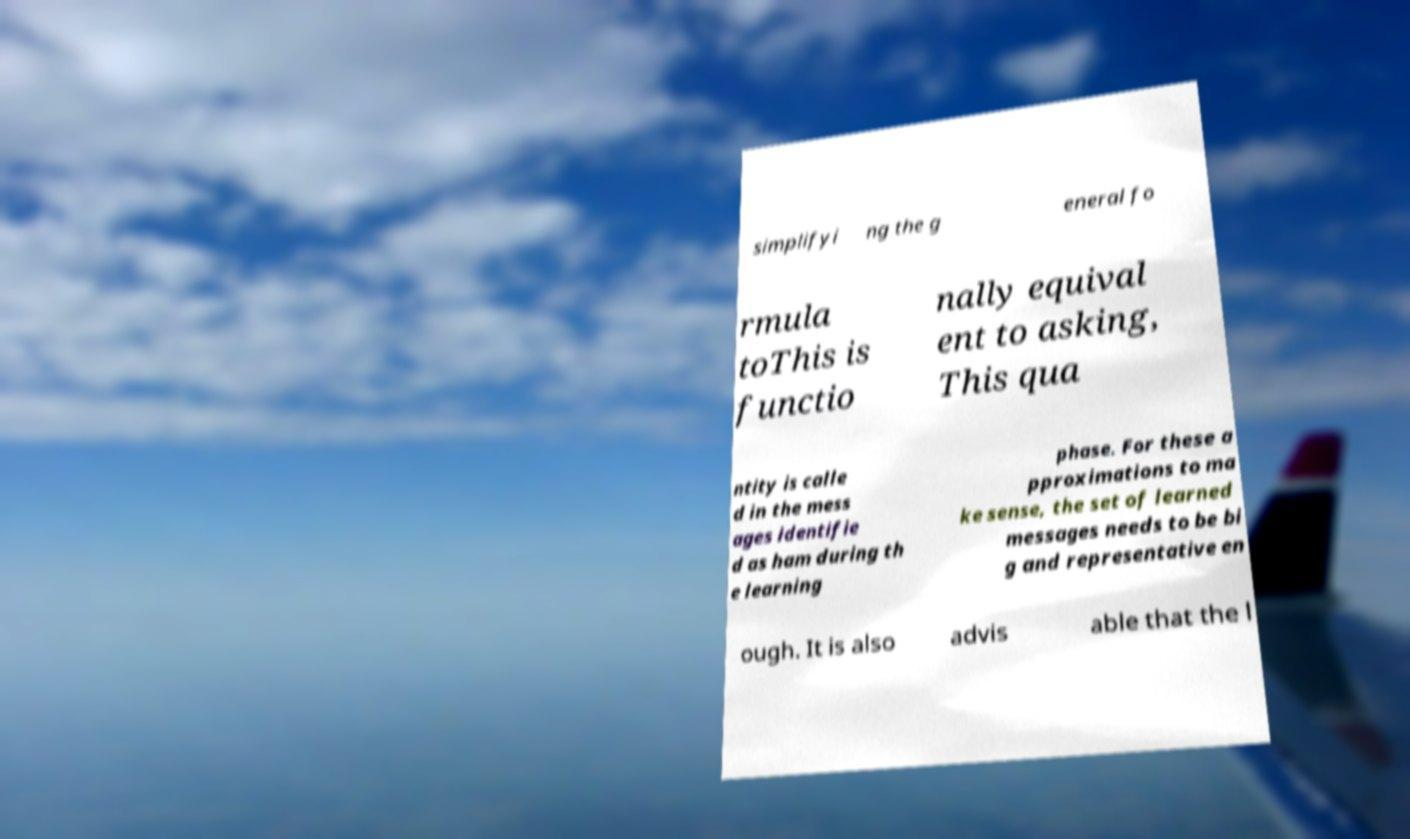Could you extract and type out the text from this image? simplifyi ng the g eneral fo rmula toThis is functio nally equival ent to asking, This qua ntity is calle d in the mess ages identifie d as ham during th e learning phase. For these a pproximations to ma ke sense, the set of learned messages needs to be bi g and representative en ough. It is also advis able that the l 